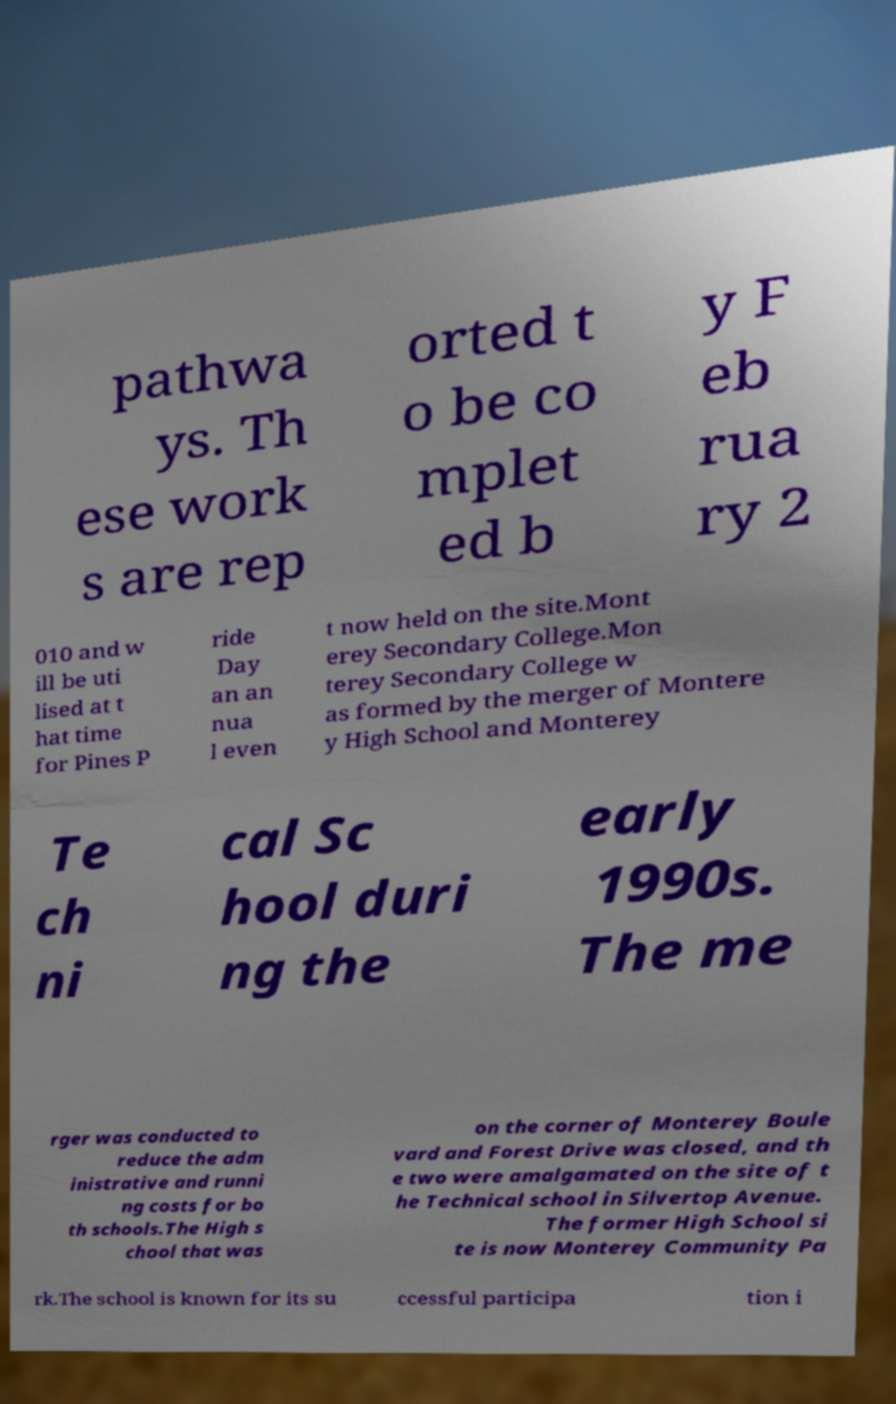Please identify and transcribe the text found in this image. pathwa ys. Th ese work s are rep orted t o be co mplet ed b y F eb rua ry 2 010 and w ill be uti lised at t hat time for Pines P ride Day an an nua l even t now held on the site.Mont erey Secondary College.Mon terey Secondary College w as formed by the merger of Montere y High School and Monterey Te ch ni cal Sc hool duri ng the early 1990s. The me rger was conducted to reduce the adm inistrative and runni ng costs for bo th schools.The High s chool that was on the corner of Monterey Boule vard and Forest Drive was closed, and th e two were amalgamated on the site of t he Technical school in Silvertop Avenue. The former High School si te is now Monterey Community Pa rk.The school is known for its su ccessful participa tion i 